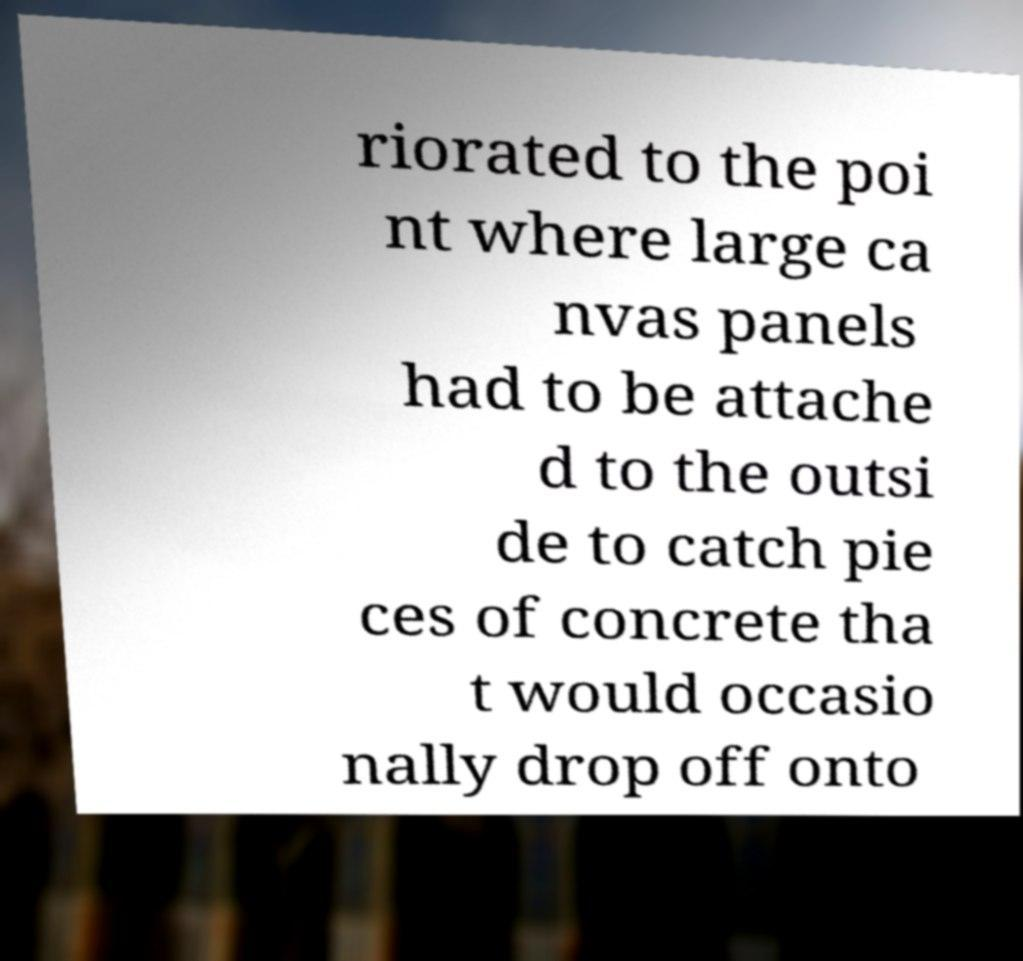Please identify and transcribe the text found in this image. riorated to the poi nt where large ca nvas panels had to be attache d to the outsi de to catch pie ces of concrete tha t would occasio nally drop off onto 